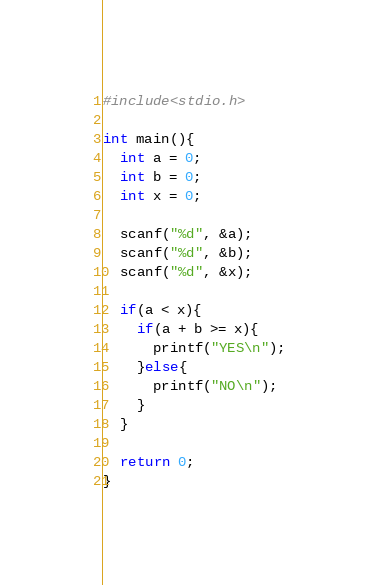Convert code to text. <code><loc_0><loc_0><loc_500><loc_500><_C_>#include<stdio.h>
 
int main(){
  int a = 0;
  int b = 0;
  int x = 0;
 
  scanf("%d", &a);
  scanf("%d", &b);
  scanf("%d", &x);
 
  if(a < x){
    if(a + b >= x){
      printf("YES\n");
    }else{
      printf("NO\n");
    }
  }
 
  return 0;
}</code> 